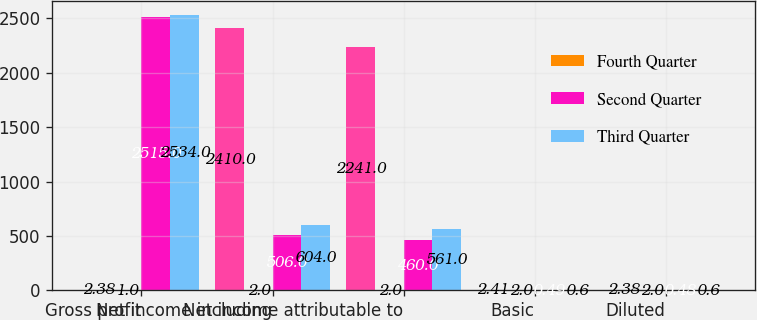Convert chart. <chart><loc_0><loc_0><loc_500><loc_500><stacked_bar_chart><ecel><fcel>Gross profit<fcel>Net income including<fcel>Net income attributable to<fcel>Basic<fcel>Diluted<nl><fcel>nan<fcel>2.38<fcel>2410<fcel>2241<fcel>2.41<fcel>2.38<nl><fcel>Fourth Quarter<fcel>1<fcel>2<fcel>2<fcel>2<fcel>2<nl><fcel>Second Quarter<fcel>2515<fcel>506<fcel>460<fcel>0.49<fcel>0.48<nl><fcel>Third Quarter<fcel>2534<fcel>604<fcel>561<fcel>0.6<fcel>0.6<nl></chart> 